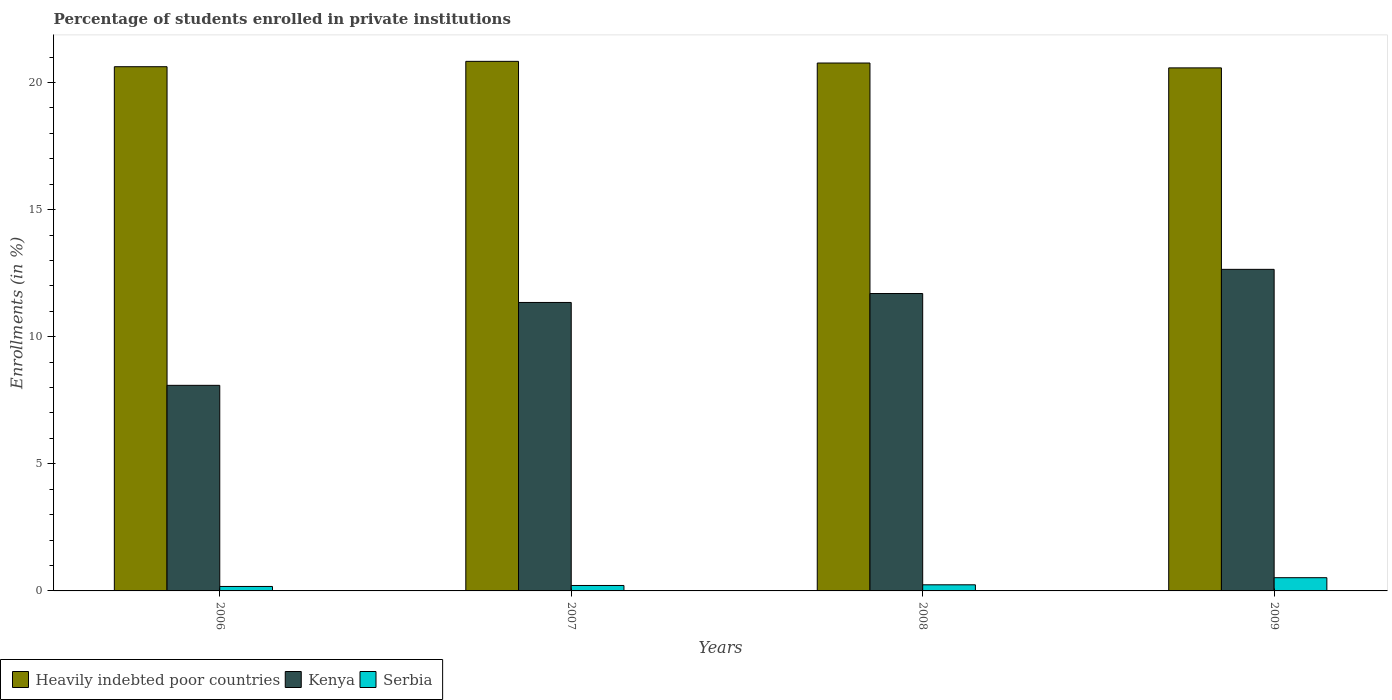Are the number of bars per tick equal to the number of legend labels?
Give a very brief answer. Yes. Are the number of bars on each tick of the X-axis equal?
Your answer should be very brief. Yes. How many bars are there on the 2nd tick from the left?
Keep it short and to the point. 3. In how many cases, is the number of bars for a given year not equal to the number of legend labels?
Give a very brief answer. 0. What is the percentage of trained teachers in Kenya in 2009?
Ensure brevity in your answer.  12.65. Across all years, what is the maximum percentage of trained teachers in Kenya?
Give a very brief answer. 12.65. Across all years, what is the minimum percentage of trained teachers in Serbia?
Offer a very short reply. 0.18. In which year was the percentage of trained teachers in Heavily indebted poor countries maximum?
Keep it short and to the point. 2007. In which year was the percentage of trained teachers in Serbia minimum?
Make the answer very short. 2006. What is the total percentage of trained teachers in Kenya in the graph?
Ensure brevity in your answer.  43.79. What is the difference between the percentage of trained teachers in Kenya in 2006 and that in 2007?
Provide a short and direct response. -3.26. What is the difference between the percentage of trained teachers in Heavily indebted poor countries in 2009 and the percentage of trained teachers in Kenya in 2006?
Ensure brevity in your answer.  12.49. What is the average percentage of trained teachers in Serbia per year?
Your answer should be compact. 0.29. In the year 2006, what is the difference between the percentage of trained teachers in Heavily indebted poor countries and percentage of trained teachers in Serbia?
Give a very brief answer. 20.45. In how many years, is the percentage of trained teachers in Heavily indebted poor countries greater than 14 %?
Give a very brief answer. 4. What is the ratio of the percentage of trained teachers in Serbia in 2006 to that in 2008?
Offer a very short reply. 0.73. Is the percentage of trained teachers in Kenya in 2006 less than that in 2008?
Your answer should be compact. Yes. What is the difference between the highest and the second highest percentage of trained teachers in Kenya?
Offer a terse response. 0.95. What is the difference between the highest and the lowest percentage of trained teachers in Heavily indebted poor countries?
Your answer should be compact. 0.26. In how many years, is the percentage of trained teachers in Heavily indebted poor countries greater than the average percentage of trained teachers in Heavily indebted poor countries taken over all years?
Keep it short and to the point. 2. Is the sum of the percentage of trained teachers in Heavily indebted poor countries in 2007 and 2008 greater than the maximum percentage of trained teachers in Kenya across all years?
Offer a very short reply. Yes. What does the 2nd bar from the left in 2006 represents?
Offer a very short reply. Kenya. What does the 2nd bar from the right in 2007 represents?
Provide a short and direct response. Kenya. Is it the case that in every year, the sum of the percentage of trained teachers in Kenya and percentage of trained teachers in Heavily indebted poor countries is greater than the percentage of trained teachers in Serbia?
Give a very brief answer. Yes. How many bars are there?
Your answer should be compact. 12. Are the values on the major ticks of Y-axis written in scientific E-notation?
Your answer should be very brief. No. Does the graph contain any zero values?
Your answer should be very brief. No. Where does the legend appear in the graph?
Your answer should be very brief. Bottom left. How many legend labels are there?
Provide a succinct answer. 3. What is the title of the graph?
Provide a succinct answer. Percentage of students enrolled in private institutions. Does "Norway" appear as one of the legend labels in the graph?
Your answer should be very brief. No. What is the label or title of the Y-axis?
Provide a succinct answer. Enrollments (in %). What is the Enrollments (in %) of Heavily indebted poor countries in 2006?
Your response must be concise. 20.62. What is the Enrollments (in %) in Kenya in 2006?
Offer a terse response. 8.09. What is the Enrollments (in %) of Serbia in 2006?
Offer a very short reply. 0.18. What is the Enrollments (in %) of Heavily indebted poor countries in 2007?
Your response must be concise. 20.83. What is the Enrollments (in %) in Kenya in 2007?
Make the answer very short. 11.35. What is the Enrollments (in %) of Serbia in 2007?
Ensure brevity in your answer.  0.21. What is the Enrollments (in %) in Heavily indebted poor countries in 2008?
Keep it short and to the point. 20.77. What is the Enrollments (in %) in Kenya in 2008?
Give a very brief answer. 11.7. What is the Enrollments (in %) in Serbia in 2008?
Give a very brief answer. 0.24. What is the Enrollments (in %) of Heavily indebted poor countries in 2009?
Keep it short and to the point. 20.58. What is the Enrollments (in %) of Kenya in 2009?
Give a very brief answer. 12.65. What is the Enrollments (in %) in Serbia in 2009?
Offer a very short reply. 0.52. Across all years, what is the maximum Enrollments (in %) of Heavily indebted poor countries?
Give a very brief answer. 20.83. Across all years, what is the maximum Enrollments (in %) of Kenya?
Offer a very short reply. 12.65. Across all years, what is the maximum Enrollments (in %) in Serbia?
Provide a succinct answer. 0.52. Across all years, what is the minimum Enrollments (in %) in Heavily indebted poor countries?
Provide a short and direct response. 20.58. Across all years, what is the minimum Enrollments (in %) in Kenya?
Keep it short and to the point. 8.09. Across all years, what is the minimum Enrollments (in %) in Serbia?
Provide a succinct answer. 0.18. What is the total Enrollments (in %) of Heavily indebted poor countries in the graph?
Offer a terse response. 82.8. What is the total Enrollments (in %) of Kenya in the graph?
Your response must be concise. 43.79. What is the total Enrollments (in %) of Serbia in the graph?
Offer a very short reply. 1.15. What is the difference between the Enrollments (in %) in Heavily indebted poor countries in 2006 and that in 2007?
Offer a terse response. -0.21. What is the difference between the Enrollments (in %) in Kenya in 2006 and that in 2007?
Provide a succinct answer. -3.26. What is the difference between the Enrollments (in %) in Serbia in 2006 and that in 2007?
Offer a terse response. -0.04. What is the difference between the Enrollments (in %) of Heavily indebted poor countries in 2006 and that in 2008?
Provide a short and direct response. -0.15. What is the difference between the Enrollments (in %) of Kenya in 2006 and that in 2008?
Your answer should be very brief. -3.61. What is the difference between the Enrollments (in %) of Serbia in 2006 and that in 2008?
Ensure brevity in your answer.  -0.07. What is the difference between the Enrollments (in %) of Heavily indebted poor countries in 2006 and that in 2009?
Keep it short and to the point. 0.05. What is the difference between the Enrollments (in %) of Kenya in 2006 and that in 2009?
Give a very brief answer. -4.56. What is the difference between the Enrollments (in %) in Serbia in 2006 and that in 2009?
Ensure brevity in your answer.  -0.34. What is the difference between the Enrollments (in %) of Heavily indebted poor countries in 2007 and that in 2008?
Provide a succinct answer. 0.07. What is the difference between the Enrollments (in %) of Kenya in 2007 and that in 2008?
Offer a very short reply. -0.35. What is the difference between the Enrollments (in %) in Serbia in 2007 and that in 2008?
Keep it short and to the point. -0.03. What is the difference between the Enrollments (in %) of Heavily indebted poor countries in 2007 and that in 2009?
Make the answer very short. 0.26. What is the difference between the Enrollments (in %) in Kenya in 2007 and that in 2009?
Provide a short and direct response. -1.3. What is the difference between the Enrollments (in %) in Serbia in 2007 and that in 2009?
Ensure brevity in your answer.  -0.31. What is the difference between the Enrollments (in %) in Heavily indebted poor countries in 2008 and that in 2009?
Keep it short and to the point. 0.19. What is the difference between the Enrollments (in %) in Kenya in 2008 and that in 2009?
Your answer should be very brief. -0.95. What is the difference between the Enrollments (in %) of Serbia in 2008 and that in 2009?
Keep it short and to the point. -0.28. What is the difference between the Enrollments (in %) in Heavily indebted poor countries in 2006 and the Enrollments (in %) in Kenya in 2007?
Your response must be concise. 9.27. What is the difference between the Enrollments (in %) in Heavily indebted poor countries in 2006 and the Enrollments (in %) in Serbia in 2007?
Offer a terse response. 20.41. What is the difference between the Enrollments (in %) in Kenya in 2006 and the Enrollments (in %) in Serbia in 2007?
Keep it short and to the point. 7.87. What is the difference between the Enrollments (in %) of Heavily indebted poor countries in 2006 and the Enrollments (in %) of Kenya in 2008?
Your answer should be compact. 8.92. What is the difference between the Enrollments (in %) in Heavily indebted poor countries in 2006 and the Enrollments (in %) in Serbia in 2008?
Give a very brief answer. 20.38. What is the difference between the Enrollments (in %) of Kenya in 2006 and the Enrollments (in %) of Serbia in 2008?
Your response must be concise. 7.85. What is the difference between the Enrollments (in %) in Heavily indebted poor countries in 2006 and the Enrollments (in %) in Kenya in 2009?
Offer a terse response. 7.97. What is the difference between the Enrollments (in %) of Heavily indebted poor countries in 2006 and the Enrollments (in %) of Serbia in 2009?
Offer a very short reply. 20.1. What is the difference between the Enrollments (in %) of Kenya in 2006 and the Enrollments (in %) of Serbia in 2009?
Provide a short and direct response. 7.57. What is the difference between the Enrollments (in %) of Heavily indebted poor countries in 2007 and the Enrollments (in %) of Kenya in 2008?
Provide a succinct answer. 9.13. What is the difference between the Enrollments (in %) in Heavily indebted poor countries in 2007 and the Enrollments (in %) in Serbia in 2008?
Give a very brief answer. 20.59. What is the difference between the Enrollments (in %) in Kenya in 2007 and the Enrollments (in %) in Serbia in 2008?
Your answer should be compact. 11.11. What is the difference between the Enrollments (in %) of Heavily indebted poor countries in 2007 and the Enrollments (in %) of Kenya in 2009?
Your answer should be compact. 8.18. What is the difference between the Enrollments (in %) of Heavily indebted poor countries in 2007 and the Enrollments (in %) of Serbia in 2009?
Make the answer very short. 20.31. What is the difference between the Enrollments (in %) of Kenya in 2007 and the Enrollments (in %) of Serbia in 2009?
Your response must be concise. 10.83. What is the difference between the Enrollments (in %) of Heavily indebted poor countries in 2008 and the Enrollments (in %) of Kenya in 2009?
Ensure brevity in your answer.  8.12. What is the difference between the Enrollments (in %) in Heavily indebted poor countries in 2008 and the Enrollments (in %) in Serbia in 2009?
Your response must be concise. 20.25. What is the difference between the Enrollments (in %) of Kenya in 2008 and the Enrollments (in %) of Serbia in 2009?
Provide a succinct answer. 11.18. What is the average Enrollments (in %) in Heavily indebted poor countries per year?
Your answer should be very brief. 20.7. What is the average Enrollments (in %) of Kenya per year?
Keep it short and to the point. 10.95. What is the average Enrollments (in %) of Serbia per year?
Offer a very short reply. 0.29. In the year 2006, what is the difference between the Enrollments (in %) of Heavily indebted poor countries and Enrollments (in %) of Kenya?
Your answer should be very brief. 12.54. In the year 2006, what is the difference between the Enrollments (in %) in Heavily indebted poor countries and Enrollments (in %) in Serbia?
Make the answer very short. 20.45. In the year 2006, what is the difference between the Enrollments (in %) in Kenya and Enrollments (in %) in Serbia?
Your answer should be compact. 7.91. In the year 2007, what is the difference between the Enrollments (in %) of Heavily indebted poor countries and Enrollments (in %) of Kenya?
Keep it short and to the point. 9.49. In the year 2007, what is the difference between the Enrollments (in %) in Heavily indebted poor countries and Enrollments (in %) in Serbia?
Ensure brevity in your answer.  20.62. In the year 2007, what is the difference between the Enrollments (in %) of Kenya and Enrollments (in %) of Serbia?
Your answer should be compact. 11.13. In the year 2008, what is the difference between the Enrollments (in %) of Heavily indebted poor countries and Enrollments (in %) of Kenya?
Make the answer very short. 9.07. In the year 2008, what is the difference between the Enrollments (in %) in Heavily indebted poor countries and Enrollments (in %) in Serbia?
Provide a succinct answer. 20.53. In the year 2008, what is the difference between the Enrollments (in %) of Kenya and Enrollments (in %) of Serbia?
Provide a short and direct response. 11.46. In the year 2009, what is the difference between the Enrollments (in %) in Heavily indebted poor countries and Enrollments (in %) in Kenya?
Your response must be concise. 7.93. In the year 2009, what is the difference between the Enrollments (in %) in Heavily indebted poor countries and Enrollments (in %) in Serbia?
Make the answer very short. 20.06. In the year 2009, what is the difference between the Enrollments (in %) in Kenya and Enrollments (in %) in Serbia?
Your answer should be compact. 12.13. What is the ratio of the Enrollments (in %) of Heavily indebted poor countries in 2006 to that in 2007?
Give a very brief answer. 0.99. What is the ratio of the Enrollments (in %) in Kenya in 2006 to that in 2007?
Offer a terse response. 0.71. What is the ratio of the Enrollments (in %) in Serbia in 2006 to that in 2007?
Your response must be concise. 0.82. What is the ratio of the Enrollments (in %) of Heavily indebted poor countries in 2006 to that in 2008?
Your answer should be very brief. 0.99. What is the ratio of the Enrollments (in %) in Kenya in 2006 to that in 2008?
Provide a succinct answer. 0.69. What is the ratio of the Enrollments (in %) of Serbia in 2006 to that in 2008?
Offer a very short reply. 0.73. What is the ratio of the Enrollments (in %) in Heavily indebted poor countries in 2006 to that in 2009?
Your answer should be compact. 1. What is the ratio of the Enrollments (in %) in Kenya in 2006 to that in 2009?
Your response must be concise. 0.64. What is the ratio of the Enrollments (in %) in Serbia in 2006 to that in 2009?
Keep it short and to the point. 0.34. What is the ratio of the Enrollments (in %) of Heavily indebted poor countries in 2007 to that in 2008?
Provide a succinct answer. 1. What is the ratio of the Enrollments (in %) in Serbia in 2007 to that in 2008?
Ensure brevity in your answer.  0.89. What is the ratio of the Enrollments (in %) in Heavily indebted poor countries in 2007 to that in 2009?
Keep it short and to the point. 1.01. What is the ratio of the Enrollments (in %) of Kenya in 2007 to that in 2009?
Offer a very short reply. 0.9. What is the ratio of the Enrollments (in %) in Serbia in 2007 to that in 2009?
Your answer should be very brief. 0.41. What is the ratio of the Enrollments (in %) of Heavily indebted poor countries in 2008 to that in 2009?
Make the answer very short. 1.01. What is the ratio of the Enrollments (in %) in Kenya in 2008 to that in 2009?
Your answer should be very brief. 0.92. What is the ratio of the Enrollments (in %) of Serbia in 2008 to that in 2009?
Make the answer very short. 0.46. What is the difference between the highest and the second highest Enrollments (in %) of Heavily indebted poor countries?
Make the answer very short. 0.07. What is the difference between the highest and the second highest Enrollments (in %) of Kenya?
Your answer should be compact. 0.95. What is the difference between the highest and the second highest Enrollments (in %) in Serbia?
Keep it short and to the point. 0.28. What is the difference between the highest and the lowest Enrollments (in %) in Heavily indebted poor countries?
Ensure brevity in your answer.  0.26. What is the difference between the highest and the lowest Enrollments (in %) in Kenya?
Your answer should be very brief. 4.56. What is the difference between the highest and the lowest Enrollments (in %) of Serbia?
Offer a terse response. 0.34. 